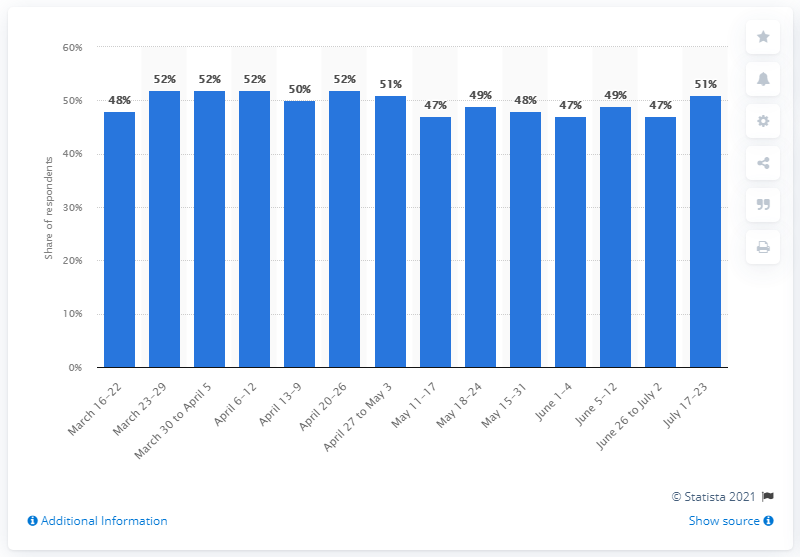Mention a couple of crucial points in this snapshot. According to the survey conducted in July 2020, 51% of respondents expressed concern about losing their jobs. 